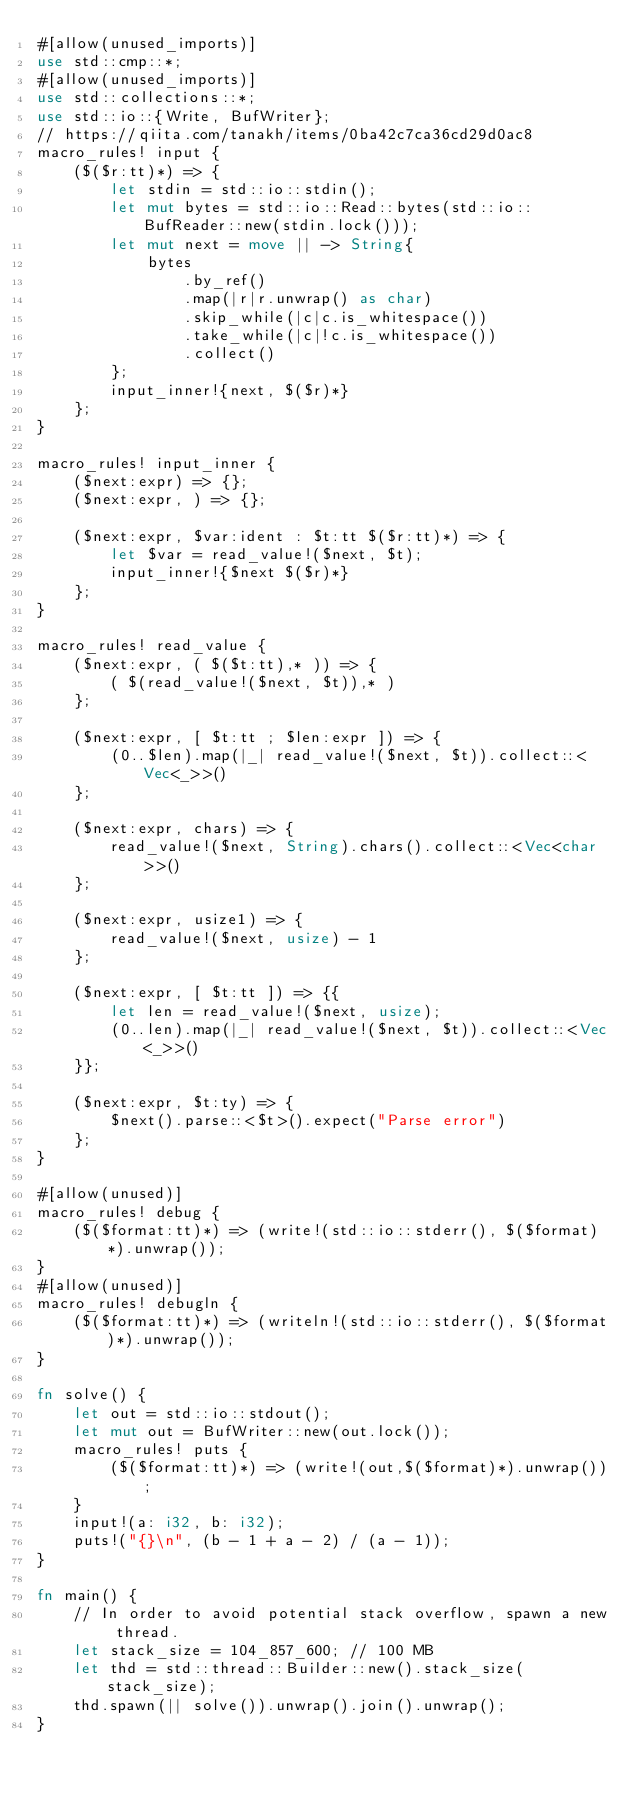<code> <loc_0><loc_0><loc_500><loc_500><_Rust_>#[allow(unused_imports)]
use std::cmp::*;
#[allow(unused_imports)]
use std::collections::*;
use std::io::{Write, BufWriter};
// https://qiita.com/tanakh/items/0ba42c7ca36cd29d0ac8
macro_rules! input {
    ($($r:tt)*) => {
        let stdin = std::io::stdin();
        let mut bytes = std::io::Read::bytes(std::io::BufReader::new(stdin.lock()));
        let mut next = move || -> String{
            bytes
                .by_ref()
                .map(|r|r.unwrap() as char)
                .skip_while(|c|c.is_whitespace())
                .take_while(|c|!c.is_whitespace())
                .collect()
        };
        input_inner!{next, $($r)*}
    };
}

macro_rules! input_inner {
    ($next:expr) => {};
    ($next:expr, ) => {};

    ($next:expr, $var:ident : $t:tt $($r:tt)*) => {
        let $var = read_value!($next, $t);
        input_inner!{$next $($r)*}
    };
}

macro_rules! read_value {
    ($next:expr, ( $($t:tt),* )) => {
        ( $(read_value!($next, $t)),* )
    };

    ($next:expr, [ $t:tt ; $len:expr ]) => {
        (0..$len).map(|_| read_value!($next, $t)).collect::<Vec<_>>()
    };

    ($next:expr, chars) => {
        read_value!($next, String).chars().collect::<Vec<char>>()
    };

    ($next:expr, usize1) => {
        read_value!($next, usize) - 1
    };

    ($next:expr, [ $t:tt ]) => {{
        let len = read_value!($next, usize);
        (0..len).map(|_| read_value!($next, $t)).collect::<Vec<_>>()
    }};

    ($next:expr, $t:ty) => {
        $next().parse::<$t>().expect("Parse error")
    };
}

#[allow(unused)]
macro_rules! debug {
    ($($format:tt)*) => (write!(std::io::stderr(), $($format)*).unwrap());
}
#[allow(unused)]
macro_rules! debugln {
    ($($format:tt)*) => (writeln!(std::io::stderr(), $($format)*).unwrap());
}

fn solve() {
    let out = std::io::stdout();
    let mut out = BufWriter::new(out.lock());
    macro_rules! puts {
        ($($format:tt)*) => (write!(out,$($format)*).unwrap());
    }
    input!(a: i32, b: i32);
    puts!("{}\n", (b - 1 + a - 2) / (a - 1));
}

fn main() {
    // In order to avoid potential stack overflow, spawn a new thread.
    let stack_size = 104_857_600; // 100 MB
    let thd = std::thread::Builder::new().stack_size(stack_size);
    thd.spawn(|| solve()).unwrap().join().unwrap();
}
</code> 